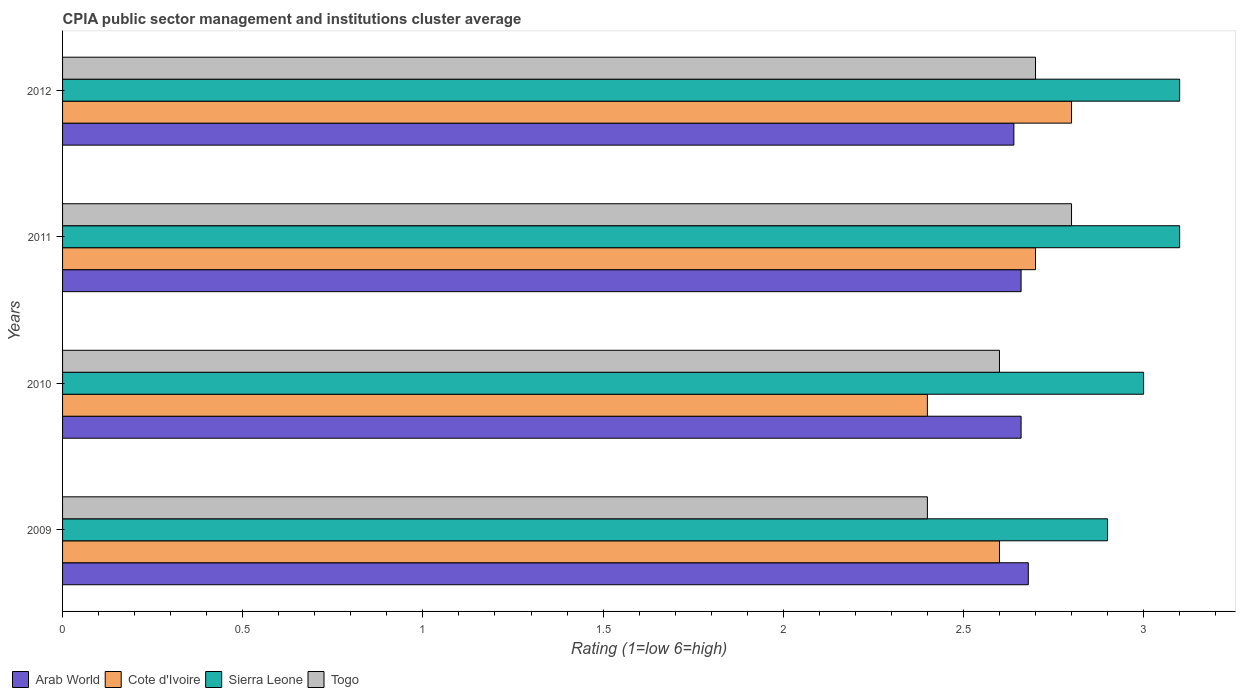How many different coloured bars are there?
Your response must be concise. 4. How many groups of bars are there?
Your response must be concise. 4. Are the number of bars on each tick of the Y-axis equal?
Your response must be concise. Yes. What is the label of the 2nd group of bars from the top?
Your answer should be very brief. 2011. What is the CPIA rating in Arab World in 2009?
Give a very brief answer. 2.68. Across all years, what is the minimum CPIA rating in Sierra Leone?
Provide a short and direct response. 2.9. In which year was the CPIA rating in Sierra Leone maximum?
Your answer should be compact. 2011. In which year was the CPIA rating in Sierra Leone minimum?
Keep it short and to the point. 2009. What is the difference between the CPIA rating in Togo in 2009 and that in 2010?
Provide a short and direct response. -0.2. What is the difference between the CPIA rating in Cote d'Ivoire in 2010 and the CPIA rating in Togo in 2012?
Your answer should be compact. -0.3. What is the average CPIA rating in Cote d'Ivoire per year?
Give a very brief answer. 2.62. In the year 2009, what is the difference between the CPIA rating in Cote d'Ivoire and CPIA rating in Arab World?
Your answer should be compact. -0.08. In how many years, is the CPIA rating in Cote d'Ivoire greater than 1.3 ?
Make the answer very short. 4. What is the ratio of the CPIA rating in Cote d'Ivoire in 2010 to that in 2012?
Your answer should be very brief. 0.86. Is the CPIA rating in Arab World in 2011 less than that in 2012?
Your answer should be compact. No. Is the difference between the CPIA rating in Cote d'Ivoire in 2009 and 2012 greater than the difference between the CPIA rating in Arab World in 2009 and 2012?
Make the answer very short. No. What is the difference between the highest and the second highest CPIA rating in Sierra Leone?
Give a very brief answer. 0. What is the difference between the highest and the lowest CPIA rating in Arab World?
Ensure brevity in your answer.  0.04. What does the 3rd bar from the top in 2011 represents?
Provide a succinct answer. Cote d'Ivoire. What does the 1st bar from the bottom in 2010 represents?
Offer a terse response. Arab World. Is it the case that in every year, the sum of the CPIA rating in Sierra Leone and CPIA rating in Togo is greater than the CPIA rating in Cote d'Ivoire?
Your answer should be very brief. Yes. How many bars are there?
Keep it short and to the point. 16. What is the difference between two consecutive major ticks on the X-axis?
Keep it short and to the point. 0.5. Does the graph contain any zero values?
Provide a short and direct response. No. Does the graph contain grids?
Provide a succinct answer. No. Where does the legend appear in the graph?
Your answer should be very brief. Bottom left. How are the legend labels stacked?
Keep it short and to the point. Horizontal. What is the title of the graph?
Make the answer very short. CPIA public sector management and institutions cluster average. Does "Virgin Islands" appear as one of the legend labels in the graph?
Provide a short and direct response. No. What is the Rating (1=low 6=high) in Arab World in 2009?
Provide a succinct answer. 2.68. What is the Rating (1=low 6=high) in Sierra Leone in 2009?
Ensure brevity in your answer.  2.9. What is the Rating (1=low 6=high) in Arab World in 2010?
Provide a short and direct response. 2.66. What is the Rating (1=low 6=high) of Arab World in 2011?
Your response must be concise. 2.66. What is the Rating (1=low 6=high) of Cote d'Ivoire in 2011?
Offer a terse response. 2.7. What is the Rating (1=low 6=high) in Togo in 2011?
Ensure brevity in your answer.  2.8. What is the Rating (1=low 6=high) of Arab World in 2012?
Make the answer very short. 2.64. Across all years, what is the maximum Rating (1=low 6=high) of Arab World?
Provide a short and direct response. 2.68. Across all years, what is the maximum Rating (1=low 6=high) in Cote d'Ivoire?
Keep it short and to the point. 2.8. Across all years, what is the maximum Rating (1=low 6=high) of Togo?
Your answer should be compact. 2.8. Across all years, what is the minimum Rating (1=low 6=high) in Arab World?
Make the answer very short. 2.64. What is the total Rating (1=low 6=high) in Arab World in the graph?
Provide a succinct answer. 10.64. What is the total Rating (1=low 6=high) of Cote d'Ivoire in the graph?
Your answer should be very brief. 10.5. What is the total Rating (1=low 6=high) in Togo in the graph?
Make the answer very short. 10.5. What is the difference between the Rating (1=low 6=high) of Cote d'Ivoire in 2009 and that in 2010?
Your answer should be compact. 0.2. What is the difference between the Rating (1=low 6=high) in Togo in 2009 and that in 2010?
Offer a terse response. -0.2. What is the difference between the Rating (1=low 6=high) of Togo in 2009 and that in 2011?
Offer a terse response. -0.4. What is the difference between the Rating (1=low 6=high) of Cote d'Ivoire in 2009 and that in 2012?
Offer a very short reply. -0.2. What is the difference between the Rating (1=low 6=high) in Cote d'Ivoire in 2010 and that in 2011?
Your response must be concise. -0.3. What is the difference between the Rating (1=low 6=high) of Sierra Leone in 2010 and that in 2011?
Provide a short and direct response. -0.1. What is the difference between the Rating (1=low 6=high) in Togo in 2010 and that in 2011?
Your response must be concise. -0.2. What is the difference between the Rating (1=low 6=high) of Arab World in 2010 and that in 2012?
Give a very brief answer. 0.02. What is the difference between the Rating (1=low 6=high) in Cote d'Ivoire in 2010 and that in 2012?
Give a very brief answer. -0.4. What is the difference between the Rating (1=low 6=high) of Sierra Leone in 2010 and that in 2012?
Keep it short and to the point. -0.1. What is the difference between the Rating (1=low 6=high) in Togo in 2010 and that in 2012?
Give a very brief answer. -0.1. What is the difference between the Rating (1=low 6=high) in Cote d'Ivoire in 2011 and that in 2012?
Provide a short and direct response. -0.1. What is the difference between the Rating (1=low 6=high) in Togo in 2011 and that in 2012?
Make the answer very short. 0.1. What is the difference between the Rating (1=low 6=high) of Arab World in 2009 and the Rating (1=low 6=high) of Cote d'Ivoire in 2010?
Keep it short and to the point. 0.28. What is the difference between the Rating (1=low 6=high) of Arab World in 2009 and the Rating (1=low 6=high) of Sierra Leone in 2010?
Provide a succinct answer. -0.32. What is the difference between the Rating (1=low 6=high) of Cote d'Ivoire in 2009 and the Rating (1=low 6=high) of Sierra Leone in 2010?
Your answer should be very brief. -0.4. What is the difference between the Rating (1=low 6=high) of Sierra Leone in 2009 and the Rating (1=low 6=high) of Togo in 2010?
Offer a very short reply. 0.3. What is the difference between the Rating (1=low 6=high) of Arab World in 2009 and the Rating (1=low 6=high) of Cote d'Ivoire in 2011?
Your answer should be very brief. -0.02. What is the difference between the Rating (1=low 6=high) of Arab World in 2009 and the Rating (1=low 6=high) of Sierra Leone in 2011?
Ensure brevity in your answer.  -0.42. What is the difference between the Rating (1=low 6=high) in Arab World in 2009 and the Rating (1=low 6=high) in Togo in 2011?
Offer a terse response. -0.12. What is the difference between the Rating (1=low 6=high) in Sierra Leone in 2009 and the Rating (1=low 6=high) in Togo in 2011?
Offer a very short reply. 0.1. What is the difference between the Rating (1=low 6=high) in Arab World in 2009 and the Rating (1=low 6=high) in Cote d'Ivoire in 2012?
Offer a very short reply. -0.12. What is the difference between the Rating (1=low 6=high) of Arab World in 2009 and the Rating (1=low 6=high) of Sierra Leone in 2012?
Make the answer very short. -0.42. What is the difference between the Rating (1=low 6=high) in Arab World in 2009 and the Rating (1=low 6=high) in Togo in 2012?
Keep it short and to the point. -0.02. What is the difference between the Rating (1=low 6=high) in Cote d'Ivoire in 2009 and the Rating (1=low 6=high) in Sierra Leone in 2012?
Keep it short and to the point. -0.5. What is the difference between the Rating (1=low 6=high) in Arab World in 2010 and the Rating (1=low 6=high) in Cote d'Ivoire in 2011?
Keep it short and to the point. -0.04. What is the difference between the Rating (1=low 6=high) in Arab World in 2010 and the Rating (1=low 6=high) in Sierra Leone in 2011?
Keep it short and to the point. -0.44. What is the difference between the Rating (1=low 6=high) in Arab World in 2010 and the Rating (1=low 6=high) in Togo in 2011?
Provide a short and direct response. -0.14. What is the difference between the Rating (1=low 6=high) of Cote d'Ivoire in 2010 and the Rating (1=low 6=high) of Sierra Leone in 2011?
Offer a very short reply. -0.7. What is the difference between the Rating (1=low 6=high) in Cote d'Ivoire in 2010 and the Rating (1=low 6=high) in Togo in 2011?
Keep it short and to the point. -0.4. What is the difference between the Rating (1=low 6=high) in Sierra Leone in 2010 and the Rating (1=low 6=high) in Togo in 2011?
Offer a very short reply. 0.2. What is the difference between the Rating (1=low 6=high) in Arab World in 2010 and the Rating (1=low 6=high) in Cote d'Ivoire in 2012?
Keep it short and to the point. -0.14. What is the difference between the Rating (1=low 6=high) of Arab World in 2010 and the Rating (1=low 6=high) of Sierra Leone in 2012?
Provide a short and direct response. -0.44. What is the difference between the Rating (1=low 6=high) in Arab World in 2010 and the Rating (1=low 6=high) in Togo in 2012?
Your response must be concise. -0.04. What is the difference between the Rating (1=low 6=high) of Cote d'Ivoire in 2010 and the Rating (1=low 6=high) of Togo in 2012?
Offer a very short reply. -0.3. What is the difference between the Rating (1=low 6=high) in Sierra Leone in 2010 and the Rating (1=low 6=high) in Togo in 2012?
Offer a very short reply. 0.3. What is the difference between the Rating (1=low 6=high) of Arab World in 2011 and the Rating (1=low 6=high) of Cote d'Ivoire in 2012?
Offer a terse response. -0.14. What is the difference between the Rating (1=low 6=high) in Arab World in 2011 and the Rating (1=low 6=high) in Sierra Leone in 2012?
Your response must be concise. -0.44. What is the difference between the Rating (1=low 6=high) of Arab World in 2011 and the Rating (1=low 6=high) of Togo in 2012?
Keep it short and to the point. -0.04. What is the difference between the Rating (1=low 6=high) in Cote d'Ivoire in 2011 and the Rating (1=low 6=high) in Sierra Leone in 2012?
Give a very brief answer. -0.4. What is the difference between the Rating (1=low 6=high) in Cote d'Ivoire in 2011 and the Rating (1=low 6=high) in Togo in 2012?
Keep it short and to the point. 0. What is the average Rating (1=low 6=high) in Arab World per year?
Provide a short and direct response. 2.66. What is the average Rating (1=low 6=high) of Cote d'Ivoire per year?
Keep it short and to the point. 2.62. What is the average Rating (1=low 6=high) in Sierra Leone per year?
Provide a short and direct response. 3.02. What is the average Rating (1=low 6=high) of Togo per year?
Provide a succinct answer. 2.62. In the year 2009, what is the difference between the Rating (1=low 6=high) of Arab World and Rating (1=low 6=high) of Cote d'Ivoire?
Give a very brief answer. 0.08. In the year 2009, what is the difference between the Rating (1=low 6=high) of Arab World and Rating (1=low 6=high) of Sierra Leone?
Offer a terse response. -0.22. In the year 2009, what is the difference between the Rating (1=low 6=high) in Arab World and Rating (1=low 6=high) in Togo?
Give a very brief answer. 0.28. In the year 2009, what is the difference between the Rating (1=low 6=high) of Cote d'Ivoire and Rating (1=low 6=high) of Togo?
Make the answer very short. 0.2. In the year 2009, what is the difference between the Rating (1=low 6=high) of Sierra Leone and Rating (1=low 6=high) of Togo?
Give a very brief answer. 0.5. In the year 2010, what is the difference between the Rating (1=low 6=high) of Arab World and Rating (1=low 6=high) of Cote d'Ivoire?
Ensure brevity in your answer.  0.26. In the year 2010, what is the difference between the Rating (1=low 6=high) of Arab World and Rating (1=low 6=high) of Sierra Leone?
Your answer should be compact. -0.34. In the year 2010, what is the difference between the Rating (1=low 6=high) of Cote d'Ivoire and Rating (1=low 6=high) of Sierra Leone?
Your response must be concise. -0.6. In the year 2010, what is the difference between the Rating (1=low 6=high) of Sierra Leone and Rating (1=low 6=high) of Togo?
Your answer should be very brief. 0.4. In the year 2011, what is the difference between the Rating (1=low 6=high) in Arab World and Rating (1=low 6=high) in Cote d'Ivoire?
Your answer should be very brief. -0.04. In the year 2011, what is the difference between the Rating (1=low 6=high) of Arab World and Rating (1=low 6=high) of Sierra Leone?
Your answer should be very brief. -0.44. In the year 2011, what is the difference between the Rating (1=low 6=high) of Arab World and Rating (1=low 6=high) of Togo?
Provide a short and direct response. -0.14. In the year 2011, what is the difference between the Rating (1=low 6=high) in Cote d'Ivoire and Rating (1=low 6=high) in Sierra Leone?
Provide a succinct answer. -0.4. In the year 2011, what is the difference between the Rating (1=low 6=high) in Cote d'Ivoire and Rating (1=low 6=high) in Togo?
Keep it short and to the point. -0.1. In the year 2011, what is the difference between the Rating (1=low 6=high) of Sierra Leone and Rating (1=low 6=high) of Togo?
Keep it short and to the point. 0.3. In the year 2012, what is the difference between the Rating (1=low 6=high) in Arab World and Rating (1=low 6=high) in Cote d'Ivoire?
Your answer should be compact. -0.16. In the year 2012, what is the difference between the Rating (1=low 6=high) in Arab World and Rating (1=low 6=high) in Sierra Leone?
Offer a very short reply. -0.46. In the year 2012, what is the difference between the Rating (1=low 6=high) in Arab World and Rating (1=low 6=high) in Togo?
Offer a very short reply. -0.06. In the year 2012, what is the difference between the Rating (1=low 6=high) in Cote d'Ivoire and Rating (1=low 6=high) in Togo?
Provide a short and direct response. 0.1. In the year 2012, what is the difference between the Rating (1=low 6=high) of Sierra Leone and Rating (1=low 6=high) of Togo?
Ensure brevity in your answer.  0.4. What is the ratio of the Rating (1=low 6=high) in Arab World in 2009 to that in 2010?
Give a very brief answer. 1.01. What is the ratio of the Rating (1=low 6=high) in Cote d'Ivoire in 2009 to that in 2010?
Ensure brevity in your answer.  1.08. What is the ratio of the Rating (1=low 6=high) in Sierra Leone in 2009 to that in 2010?
Your response must be concise. 0.97. What is the ratio of the Rating (1=low 6=high) in Togo in 2009 to that in 2010?
Offer a terse response. 0.92. What is the ratio of the Rating (1=low 6=high) of Arab World in 2009 to that in 2011?
Provide a succinct answer. 1.01. What is the ratio of the Rating (1=low 6=high) in Cote d'Ivoire in 2009 to that in 2011?
Provide a short and direct response. 0.96. What is the ratio of the Rating (1=low 6=high) in Sierra Leone in 2009 to that in 2011?
Your answer should be very brief. 0.94. What is the ratio of the Rating (1=low 6=high) in Arab World in 2009 to that in 2012?
Provide a succinct answer. 1.02. What is the ratio of the Rating (1=low 6=high) of Sierra Leone in 2009 to that in 2012?
Offer a terse response. 0.94. What is the ratio of the Rating (1=low 6=high) in Arab World in 2010 to that in 2011?
Your answer should be very brief. 1. What is the ratio of the Rating (1=low 6=high) in Sierra Leone in 2010 to that in 2011?
Your response must be concise. 0.97. What is the ratio of the Rating (1=low 6=high) in Togo in 2010 to that in 2011?
Your answer should be compact. 0.93. What is the ratio of the Rating (1=low 6=high) in Arab World in 2010 to that in 2012?
Offer a terse response. 1.01. What is the ratio of the Rating (1=low 6=high) in Arab World in 2011 to that in 2012?
Ensure brevity in your answer.  1.01. What is the ratio of the Rating (1=low 6=high) in Cote d'Ivoire in 2011 to that in 2012?
Your response must be concise. 0.96. What is the ratio of the Rating (1=low 6=high) of Sierra Leone in 2011 to that in 2012?
Offer a very short reply. 1. What is the difference between the highest and the second highest Rating (1=low 6=high) of Sierra Leone?
Provide a succinct answer. 0. 